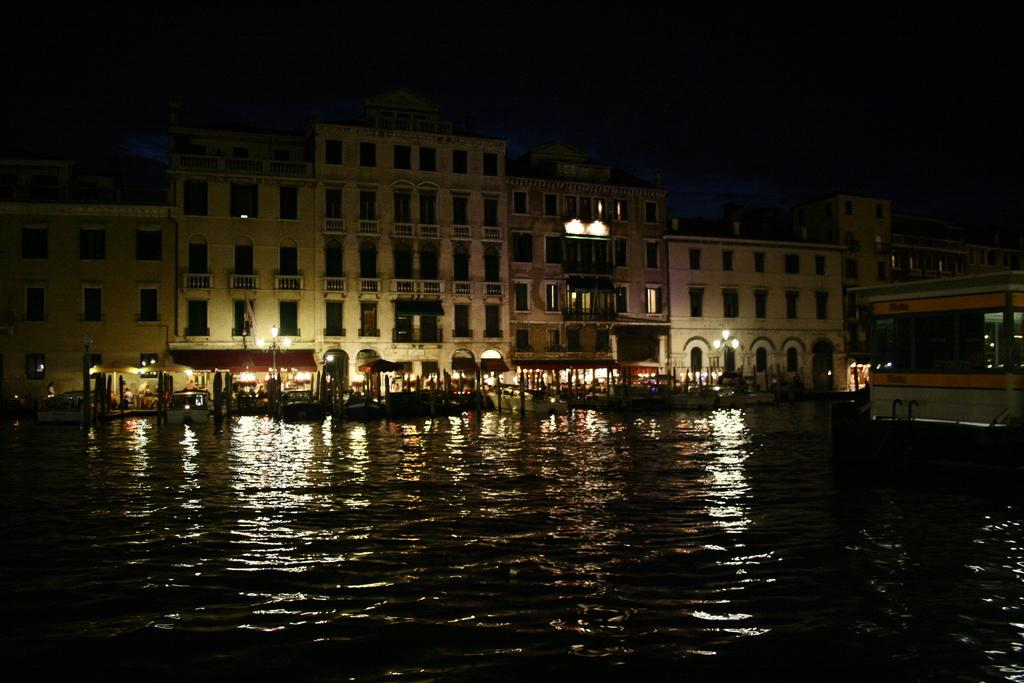What is visible in the image? Water is visible in the image. What can be seen in the background of the image? There are buildings, lights, and windows in the background of the image. Who is the owner of the baseball in the image? There is no baseball present in the image. What type of calculator can be seen on the windowsill in the image? There is no calculator visible in the image. 